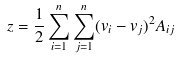Convert formula to latex. <formula><loc_0><loc_0><loc_500><loc_500>z = \frac { 1 } { 2 } \sum _ { i = 1 } ^ { n } \sum _ { j = 1 } ^ { n } ( v _ { i } - v _ { j } ) ^ { 2 } A _ { i j }</formula> 